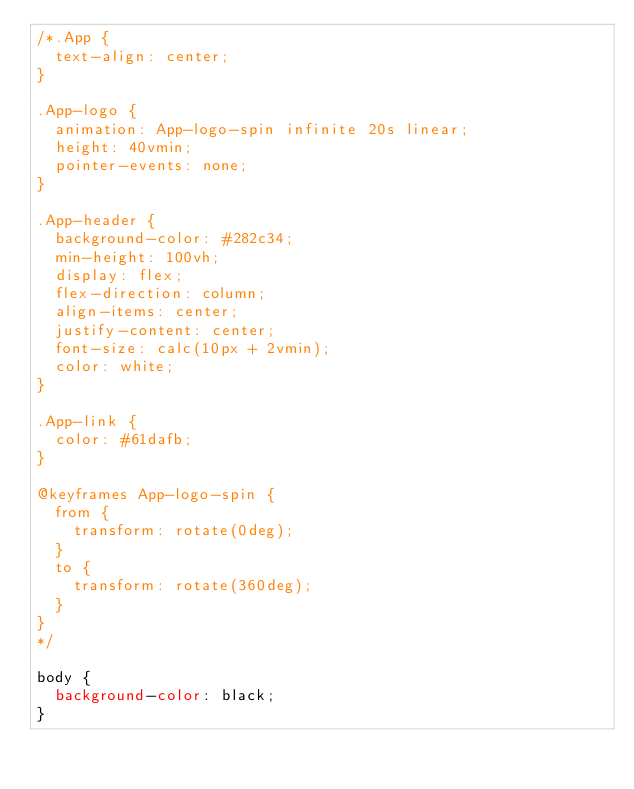<code> <loc_0><loc_0><loc_500><loc_500><_CSS_>/*.App {
  text-align: center;
}

.App-logo {
  animation: App-logo-spin infinite 20s linear;
  height: 40vmin;
  pointer-events: none;
}

.App-header {
  background-color: #282c34;
  min-height: 100vh;
  display: flex;
  flex-direction: column;
  align-items: center;
  justify-content: center;
  font-size: calc(10px + 2vmin);
  color: white;
}

.App-link {
  color: #61dafb;
}

@keyframes App-logo-spin {
  from {
    transform: rotate(0deg);
  }
  to {
    transform: rotate(360deg);
  }
}
*/

body {
  background-color: black;
}
</code> 